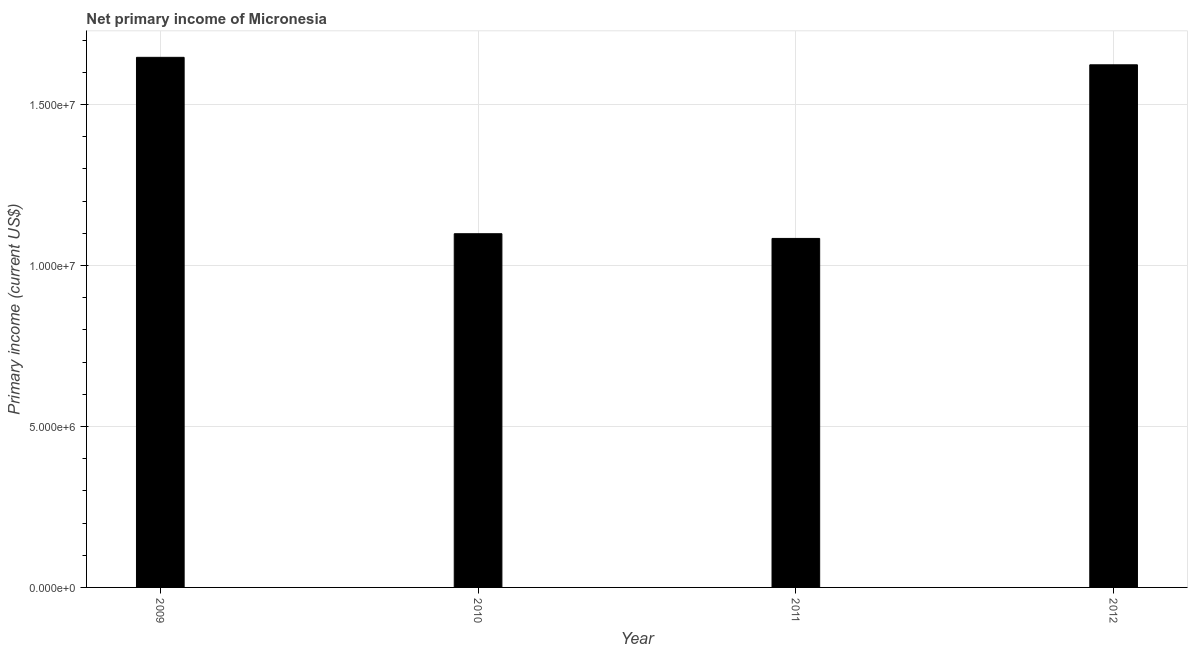What is the title of the graph?
Offer a very short reply. Net primary income of Micronesia. What is the label or title of the X-axis?
Your response must be concise. Year. What is the label or title of the Y-axis?
Offer a very short reply. Primary income (current US$). What is the amount of primary income in 2009?
Provide a succinct answer. 1.65e+07. Across all years, what is the maximum amount of primary income?
Keep it short and to the point. 1.65e+07. Across all years, what is the minimum amount of primary income?
Provide a short and direct response. 1.08e+07. In which year was the amount of primary income maximum?
Offer a very short reply. 2009. In which year was the amount of primary income minimum?
Make the answer very short. 2011. What is the sum of the amount of primary income?
Offer a very short reply. 5.45e+07. What is the difference between the amount of primary income in 2009 and 2010?
Provide a short and direct response. 5.48e+06. What is the average amount of primary income per year?
Ensure brevity in your answer.  1.36e+07. What is the median amount of primary income?
Offer a terse response. 1.36e+07. What is the ratio of the amount of primary income in 2010 to that in 2011?
Your response must be concise. 1.01. Is the amount of primary income in 2009 less than that in 2012?
Provide a succinct answer. No. What is the difference between the highest and the second highest amount of primary income?
Provide a short and direct response. 2.32e+05. What is the difference between the highest and the lowest amount of primary income?
Provide a short and direct response. 5.62e+06. In how many years, is the amount of primary income greater than the average amount of primary income taken over all years?
Your answer should be compact. 2. How many bars are there?
Provide a succinct answer. 4. How many years are there in the graph?
Your response must be concise. 4. What is the difference between two consecutive major ticks on the Y-axis?
Offer a very short reply. 5.00e+06. Are the values on the major ticks of Y-axis written in scientific E-notation?
Give a very brief answer. Yes. What is the Primary income (current US$) of 2009?
Provide a succinct answer. 1.65e+07. What is the Primary income (current US$) of 2010?
Ensure brevity in your answer.  1.10e+07. What is the Primary income (current US$) of 2011?
Offer a terse response. 1.08e+07. What is the Primary income (current US$) in 2012?
Offer a terse response. 1.62e+07. What is the difference between the Primary income (current US$) in 2009 and 2010?
Offer a very short reply. 5.48e+06. What is the difference between the Primary income (current US$) in 2009 and 2011?
Your answer should be compact. 5.62e+06. What is the difference between the Primary income (current US$) in 2009 and 2012?
Your response must be concise. 2.32e+05. What is the difference between the Primary income (current US$) in 2010 and 2011?
Keep it short and to the point. 1.46e+05. What is the difference between the Primary income (current US$) in 2010 and 2012?
Give a very brief answer. -5.25e+06. What is the difference between the Primary income (current US$) in 2011 and 2012?
Give a very brief answer. -5.39e+06. What is the ratio of the Primary income (current US$) in 2009 to that in 2010?
Ensure brevity in your answer.  1.5. What is the ratio of the Primary income (current US$) in 2009 to that in 2011?
Offer a terse response. 1.52. What is the ratio of the Primary income (current US$) in 2010 to that in 2012?
Offer a very short reply. 0.68. What is the ratio of the Primary income (current US$) in 2011 to that in 2012?
Your answer should be very brief. 0.67. 